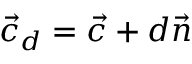<formula> <loc_0><loc_0><loc_500><loc_500>{ \vec { c } } _ { d } = { \vec { c } } + d { \vec { n } }</formula> 